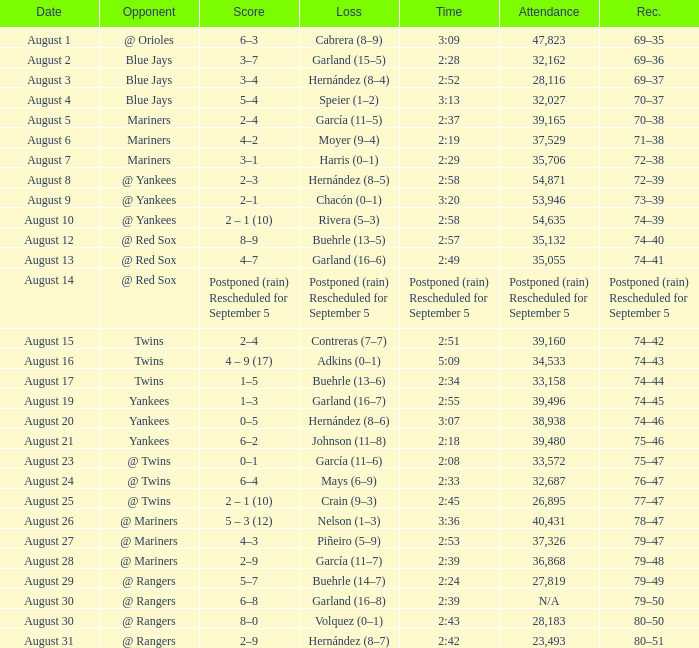Who lost on August 27? Piñeiro (5–9). 